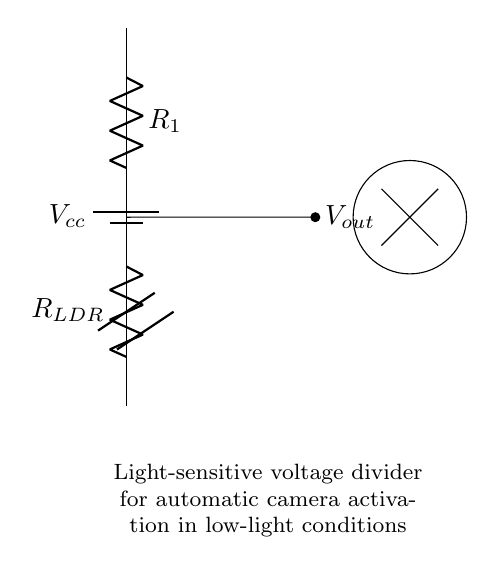What is the output voltage labeled? The output voltage in the circuit is labeled as Vout, which indicates the voltage measured across the output terminals of the voltage divider.
Answer: Vout What components are present in the voltage divider? The circuit diagram includes two resistors: R1 and R_LDR, with R_LDR being a light-dependent resistor that varies its resistance based on light conditions.
Answer: R1, R_LDR What is the primary purpose of R_LDR in this circuit? R_LDR acts as a light-sensitive element in the voltage divider, changing its resistance depending on the ambient light level, which impacts the Vout and ultimately activates the camera in low light.
Answer: Activation in low light What connects to the voltage divider's output? The output, labeled as Vout, is connected to the surveillance camera, which will be activated based on the voltage level at that point determined by the voltage divider action.
Answer: Surveillance camera If light is bright, what happens to Vout? When light is bright, the resistance of R_LDR decreases, leading to an increase in Vout since there is less voltage drop across the LDR, which means the camera likely remains off.
Answer: Vout increases What is the voltage source in the circuit? The voltage source is labeled as Vcc, providing the necessary electrical energy for the circuit to function. This voltage is the total supply voltage for the circuit.
Answer: Vcc How is the circuit diagram functioning as an automatic activation system? The voltage divider creates a varying output voltage based on the light conditions sensed by R_LDR. When low light causes Vout to cross a certain threshold, it activates the surveillance camera automatically.
Answer: Automatic activation 